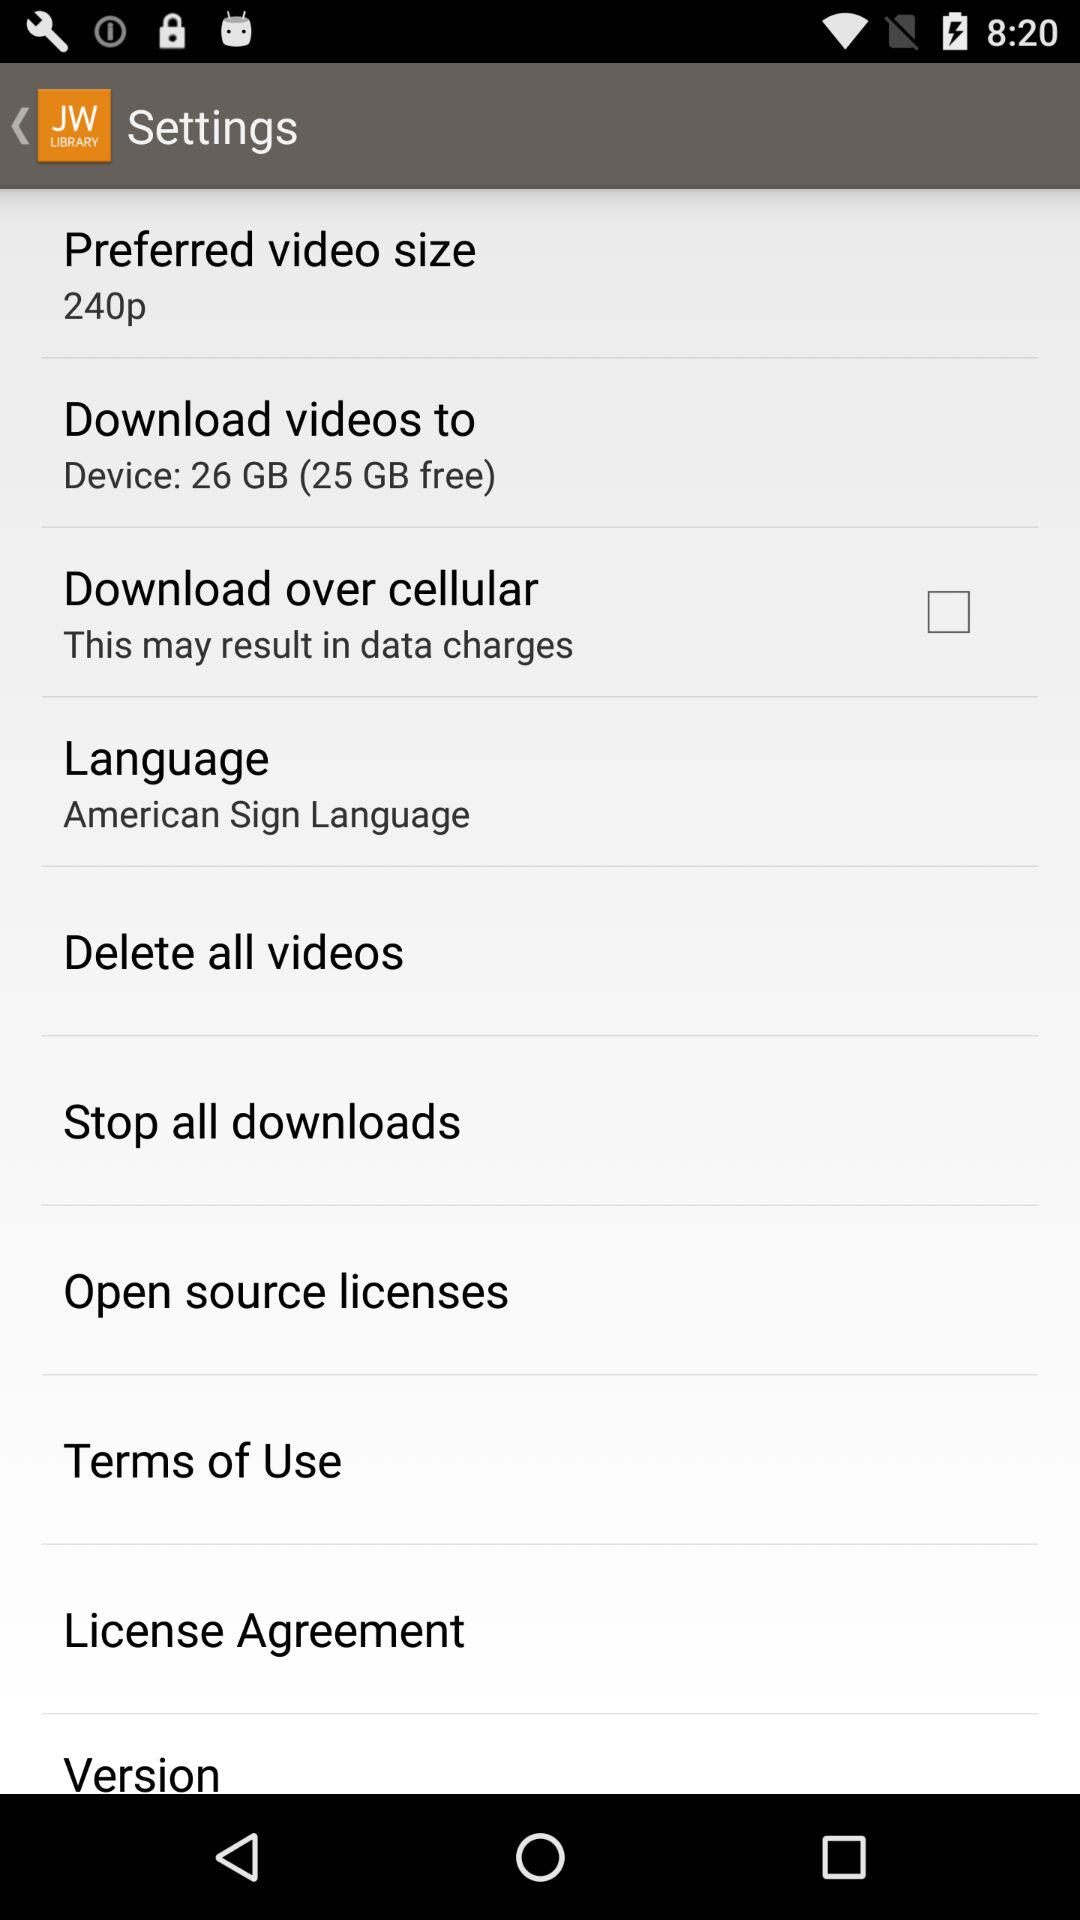What is the preferred video size? The preferred video size is 240p. 